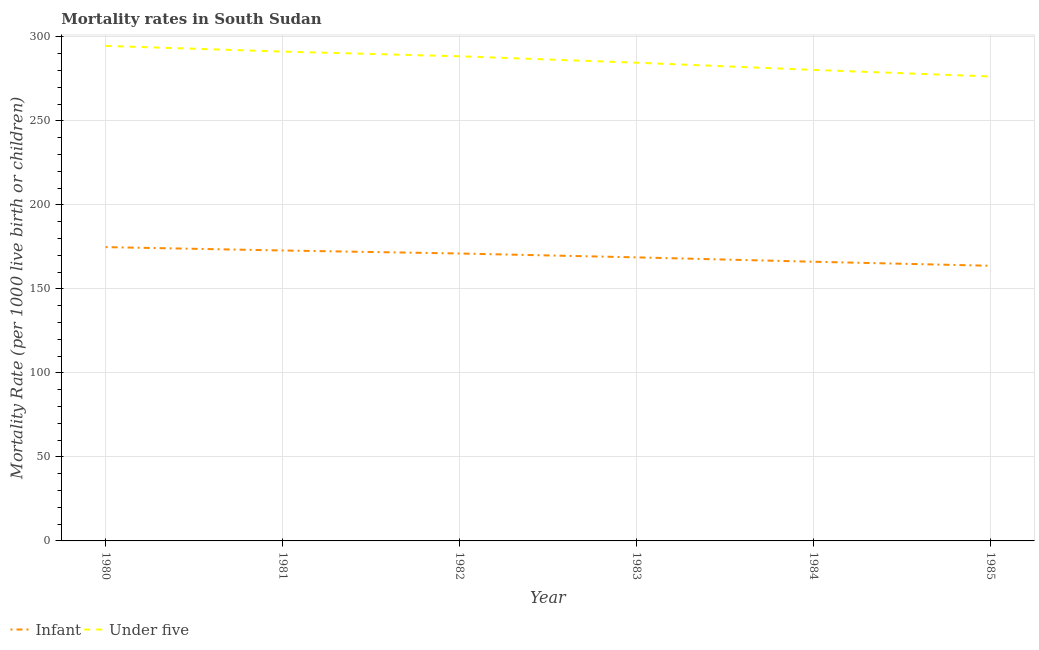How many different coloured lines are there?
Make the answer very short. 2. Is the number of lines equal to the number of legend labels?
Your answer should be very brief. Yes. What is the infant mortality rate in 1985?
Provide a short and direct response. 163.8. Across all years, what is the maximum infant mortality rate?
Your answer should be compact. 174.9. Across all years, what is the minimum under-5 mortality rate?
Ensure brevity in your answer.  276.5. In which year was the infant mortality rate maximum?
Give a very brief answer. 1980. What is the total infant mortality rate in the graph?
Keep it short and to the point. 1017.7. What is the difference between the infant mortality rate in 1982 and that in 1983?
Give a very brief answer. 2.3. What is the difference between the under-5 mortality rate in 1980 and the infant mortality rate in 1981?
Provide a succinct answer. 121.8. What is the average infant mortality rate per year?
Provide a succinct answer. 169.62. In the year 1983, what is the difference between the under-5 mortality rate and infant mortality rate?
Your answer should be very brief. 115.9. In how many years, is the infant mortality rate greater than 290?
Provide a short and direct response. 0. What is the ratio of the under-5 mortality rate in 1980 to that in 1983?
Give a very brief answer. 1.04. Is the under-5 mortality rate in 1980 less than that in 1982?
Provide a short and direct response. No. Is the difference between the under-5 mortality rate in 1981 and 1985 greater than the difference between the infant mortality rate in 1981 and 1985?
Give a very brief answer. Yes. What is the difference between the highest and the lowest infant mortality rate?
Provide a succinct answer. 11.1. Is the sum of the under-5 mortality rate in 1981 and 1985 greater than the maximum infant mortality rate across all years?
Your response must be concise. Yes. Is the infant mortality rate strictly less than the under-5 mortality rate over the years?
Make the answer very short. Yes. How many lines are there?
Your response must be concise. 2. What is the difference between two consecutive major ticks on the Y-axis?
Provide a short and direct response. 50. Are the values on the major ticks of Y-axis written in scientific E-notation?
Ensure brevity in your answer.  No. Where does the legend appear in the graph?
Give a very brief answer. Bottom left. What is the title of the graph?
Your answer should be compact. Mortality rates in South Sudan. What is the label or title of the X-axis?
Your answer should be very brief. Year. What is the label or title of the Y-axis?
Give a very brief answer. Mortality Rate (per 1000 live birth or children). What is the Mortality Rate (per 1000 live birth or children) of Infant in 1980?
Your answer should be compact. 174.9. What is the Mortality Rate (per 1000 live birth or children) in Under five in 1980?
Offer a terse response. 294.7. What is the Mortality Rate (per 1000 live birth or children) of Infant in 1981?
Provide a succinct answer. 172.9. What is the Mortality Rate (per 1000 live birth or children) of Under five in 1981?
Ensure brevity in your answer.  291.3. What is the Mortality Rate (per 1000 live birth or children) in Infant in 1982?
Provide a succinct answer. 171.1. What is the Mortality Rate (per 1000 live birth or children) of Under five in 1982?
Provide a short and direct response. 288.5. What is the Mortality Rate (per 1000 live birth or children) in Infant in 1983?
Keep it short and to the point. 168.8. What is the Mortality Rate (per 1000 live birth or children) of Under five in 1983?
Provide a short and direct response. 284.7. What is the Mortality Rate (per 1000 live birth or children) in Infant in 1984?
Offer a terse response. 166.2. What is the Mortality Rate (per 1000 live birth or children) of Under five in 1984?
Provide a succinct answer. 280.4. What is the Mortality Rate (per 1000 live birth or children) in Infant in 1985?
Your response must be concise. 163.8. What is the Mortality Rate (per 1000 live birth or children) of Under five in 1985?
Your answer should be very brief. 276.5. Across all years, what is the maximum Mortality Rate (per 1000 live birth or children) of Infant?
Provide a short and direct response. 174.9. Across all years, what is the maximum Mortality Rate (per 1000 live birth or children) in Under five?
Keep it short and to the point. 294.7. Across all years, what is the minimum Mortality Rate (per 1000 live birth or children) of Infant?
Your response must be concise. 163.8. Across all years, what is the minimum Mortality Rate (per 1000 live birth or children) in Under five?
Ensure brevity in your answer.  276.5. What is the total Mortality Rate (per 1000 live birth or children) in Infant in the graph?
Ensure brevity in your answer.  1017.7. What is the total Mortality Rate (per 1000 live birth or children) in Under five in the graph?
Provide a short and direct response. 1716.1. What is the difference between the Mortality Rate (per 1000 live birth or children) in Infant in 1980 and that in 1983?
Offer a very short reply. 6.1. What is the difference between the Mortality Rate (per 1000 live birth or children) in Under five in 1980 and that in 1983?
Ensure brevity in your answer.  10. What is the difference between the Mortality Rate (per 1000 live birth or children) of Infant in 1980 and that in 1984?
Keep it short and to the point. 8.7. What is the difference between the Mortality Rate (per 1000 live birth or children) in Infant in 1981 and that in 1983?
Your answer should be compact. 4.1. What is the difference between the Mortality Rate (per 1000 live birth or children) in Under five in 1981 and that in 1984?
Provide a succinct answer. 10.9. What is the difference between the Mortality Rate (per 1000 live birth or children) in Under five in 1981 and that in 1985?
Ensure brevity in your answer.  14.8. What is the difference between the Mortality Rate (per 1000 live birth or children) of Infant in 1982 and that in 1984?
Your answer should be compact. 4.9. What is the difference between the Mortality Rate (per 1000 live birth or children) in Infant in 1983 and that in 1984?
Provide a short and direct response. 2.6. What is the difference between the Mortality Rate (per 1000 live birth or children) of Infant in 1984 and that in 1985?
Keep it short and to the point. 2.4. What is the difference between the Mortality Rate (per 1000 live birth or children) of Infant in 1980 and the Mortality Rate (per 1000 live birth or children) of Under five in 1981?
Offer a very short reply. -116.4. What is the difference between the Mortality Rate (per 1000 live birth or children) of Infant in 1980 and the Mortality Rate (per 1000 live birth or children) of Under five in 1982?
Keep it short and to the point. -113.6. What is the difference between the Mortality Rate (per 1000 live birth or children) in Infant in 1980 and the Mortality Rate (per 1000 live birth or children) in Under five in 1983?
Give a very brief answer. -109.8. What is the difference between the Mortality Rate (per 1000 live birth or children) of Infant in 1980 and the Mortality Rate (per 1000 live birth or children) of Under five in 1984?
Give a very brief answer. -105.5. What is the difference between the Mortality Rate (per 1000 live birth or children) of Infant in 1980 and the Mortality Rate (per 1000 live birth or children) of Under five in 1985?
Offer a very short reply. -101.6. What is the difference between the Mortality Rate (per 1000 live birth or children) of Infant in 1981 and the Mortality Rate (per 1000 live birth or children) of Under five in 1982?
Your answer should be compact. -115.6. What is the difference between the Mortality Rate (per 1000 live birth or children) in Infant in 1981 and the Mortality Rate (per 1000 live birth or children) in Under five in 1983?
Make the answer very short. -111.8. What is the difference between the Mortality Rate (per 1000 live birth or children) in Infant in 1981 and the Mortality Rate (per 1000 live birth or children) in Under five in 1984?
Offer a very short reply. -107.5. What is the difference between the Mortality Rate (per 1000 live birth or children) in Infant in 1981 and the Mortality Rate (per 1000 live birth or children) in Under five in 1985?
Your response must be concise. -103.6. What is the difference between the Mortality Rate (per 1000 live birth or children) of Infant in 1982 and the Mortality Rate (per 1000 live birth or children) of Under five in 1983?
Keep it short and to the point. -113.6. What is the difference between the Mortality Rate (per 1000 live birth or children) in Infant in 1982 and the Mortality Rate (per 1000 live birth or children) in Under five in 1984?
Provide a succinct answer. -109.3. What is the difference between the Mortality Rate (per 1000 live birth or children) in Infant in 1982 and the Mortality Rate (per 1000 live birth or children) in Under five in 1985?
Your response must be concise. -105.4. What is the difference between the Mortality Rate (per 1000 live birth or children) of Infant in 1983 and the Mortality Rate (per 1000 live birth or children) of Under five in 1984?
Provide a short and direct response. -111.6. What is the difference between the Mortality Rate (per 1000 live birth or children) of Infant in 1983 and the Mortality Rate (per 1000 live birth or children) of Under five in 1985?
Offer a terse response. -107.7. What is the difference between the Mortality Rate (per 1000 live birth or children) in Infant in 1984 and the Mortality Rate (per 1000 live birth or children) in Under five in 1985?
Provide a succinct answer. -110.3. What is the average Mortality Rate (per 1000 live birth or children) in Infant per year?
Make the answer very short. 169.62. What is the average Mortality Rate (per 1000 live birth or children) in Under five per year?
Your answer should be compact. 286.02. In the year 1980, what is the difference between the Mortality Rate (per 1000 live birth or children) of Infant and Mortality Rate (per 1000 live birth or children) of Under five?
Provide a succinct answer. -119.8. In the year 1981, what is the difference between the Mortality Rate (per 1000 live birth or children) of Infant and Mortality Rate (per 1000 live birth or children) of Under five?
Your answer should be very brief. -118.4. In the year 1982, what is the difference between the Mortality Rate (per 1000 live birth or children) in Infant and Mortality Rate (per 1000 live birth or children) in Under five?
Provide a short and direct response. -117.4. In the year 1983, what is the difference between the Mortality Rate (per 1000 live birth or children) of Infant and Mortality Rate (per 1000 live birth or children) of Under five?
Give a very brief answer. -115.9. In the year 1984, what is the difference between the Mortality Rate (per 1000 live birth or children) of Infant and Mortality Rate (per 1000 live birth or children) of Under five?
Your answer should be compact. -114.2. In the year 1985, what is the difference between the Mortality Rate (per 1000 live birth or children) of Infant and Mortality Rate (per 1000 live birth or children) of Under five?
Keep it short and to the point. -112.7. What is the ratio of the Mortality Rate (per 1000 live birth or children) in Infant in 1980 to that in 1981?
Offer a terse response. 1.01. What is the ratio of the Mortality Rate (per 1000 live birth or children) of Under five in 1980 to that in 1981?
Your answer should be compact. 1.01. What is the ratio of the Mortality Rate (per 1000 live birth or children) in Infant in 1980 to that in 1982?
Provide a short and direct response. 1.02. What is the ratio of the Mortality Rate (per 1000 live birth or children) of Under five in 1980 to that in 1982?
Your answer should be compact. 1.02. What is the ratio of the Mortality Rate (per 1000 live birth or children) of Infant in 1980 to that in 1983?
Provide a short and direct response. 1.04. What is the ratio of the Mortality Rate (per 1000 live birth or children) of Under five in 1980 to that in 1983?
Your answer should be very brief. 1.04. What is the ratio of the Mortality Rate (per 1000 live birth or children) in Infant in 1980 to that in 1984?
Ensure brevity in your answer.  1.05. What is the ratio of the Mortality Rate (per 1000 live birth or children) in Under five in 1980 to that in 1984?
Provide a succinct answer. 1.05. What is the ratio of the Mortality Rate (per 1000 live birth or children) in Infant in 1980 to that in 1985?
Give a very brief answer. 1.07. What is the ratio of the Mortality Rate (per 1000 live birth or children) in Under five in 1980 to that in 1985?
Keep it short and to the point. 1.07. What is the ratio of the Mortality Rate (per 1000 live birth or children) in Infant in 1981 to that in 1982?
Offer a terse response. 1.01. What is the ratio of the Mortality Rate (per 1000 live birth or children) in Under five in 1981 to that in 1982?
Provide a succinct answer. 1.01. What is the ratio of the Mortality Rate (per 1000 live birth or children) of Infant in 1981 to that in 1983?
Offer a terse response. 1.02. What is the ratio of the Mortality Rate (per 1000 live birth or children) of Under five in 1981 to that in 1983?
Keep it short and to the point. 1.02. What is the ratio of the Mortality Rate (per 1000 live birth or children) of Infant in 1981 to that in 1984?
Offer a terse response. 1.04. What is the ratio of the Mortality Rate (per 1000 live birth or children) of Under five in 1981 to that in 1984?
Offer a terse response. 1.04. What is the ratio of the Mortality Rate (per 1000 live birth or children) in Infant in 1981 to that in 1985?
Give a very brief answer. 1.06. What is the ratio of the Mortality Rate (per 1000 live birth or children) in Under five in 1981 to that in 1985?
Your response must be concise. 1.05. What is the ratio of the Mortality Rate (per 1000 live birth or children) in Infant in 1982 to that in 1983?
Give a very brief answer. 1.01. What is the ratio of the Mortality Rate (per 1000 live birth or children) in Under five in 1982 to that in 1983?
Provide a succinct answer. 1.01. What is the ratio of the Mortality Rate (per 1000 live birth or children) of Infant in 1982 to that in 1984?
Give a very brief answer. 1.03. What is the ratio of the Mortality Rate (per 1000 live birth or children) in Under five in 1982 to that in 1984?
Make the answer very short. 1.03. What is the ratio of the Mortality Rate (per 1000 live birth or children) in Infant in 1982 to that in 1985?
Your answer should be compact. 1.04. What is the ratio of the Mortality Rate (per 1000 live birth or children) of Under five in 1982 to that in 1985?
Provide a succinct answer. 1.04. What is the ratio of the Mortality Rate (per 1000 live birth or children) in Infant in 1983 to that in 1984?
Your answer should be compact. 1.02. What is the ratio of the Mortality Rate (per 1000 live birth or children) of Under five in 1983 to that in 1984?
Ensure brevity in your answer.  1.02. What is the ratio of the Mortality Rate (per 1000 live birth or children) of Infant in 1983 to that in 1985?
Offer a terse response. 1.03. What is the ratio of the Mortality Rate (per 1000 live birth or children) in Under five in 1983 to that in 1985?
Offer a very short reply. 1.03. What is the ratio of the Mortality Rate (per 1000 live birth or children) of Infant in 1984 to that in 1985?
Ensure brevity in your answer.  1.01. What is the ratio of the Mortality Rate (per 1000 live birth or children) of Under five in 1984 to that in 1985?
Ensure brevity in your answer.  1.01. What is the difference between the highest and the second highest Mortality Rate (per 1000 live birth or children) in Under five?
Give a very brief answer. 3.4. 